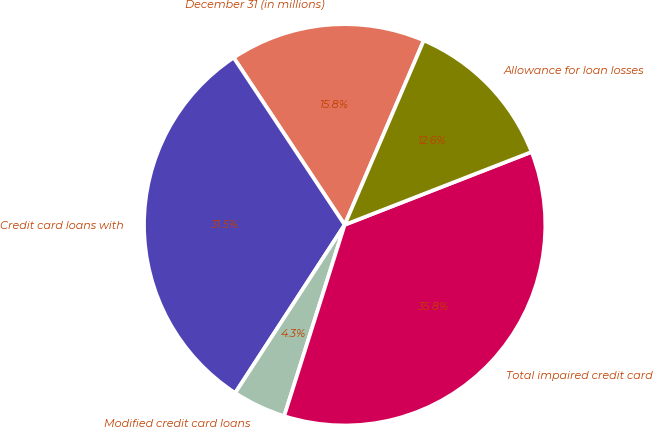Convert chart to OTSL. <chart><loc_0><loc_0><loc_500><loc_500><pie_chart><fcel>December 31 (in millions)<fcel>Credit card loans with<fcel>Modified credit card loans<fcel>Total impaired credit card<fcel>Allowance for loan losses<nl><fcel>15.78%<fcel>31.48%<fcel>4.31%<fcel>35.79%<fcel>12.63%<nl></chart> 